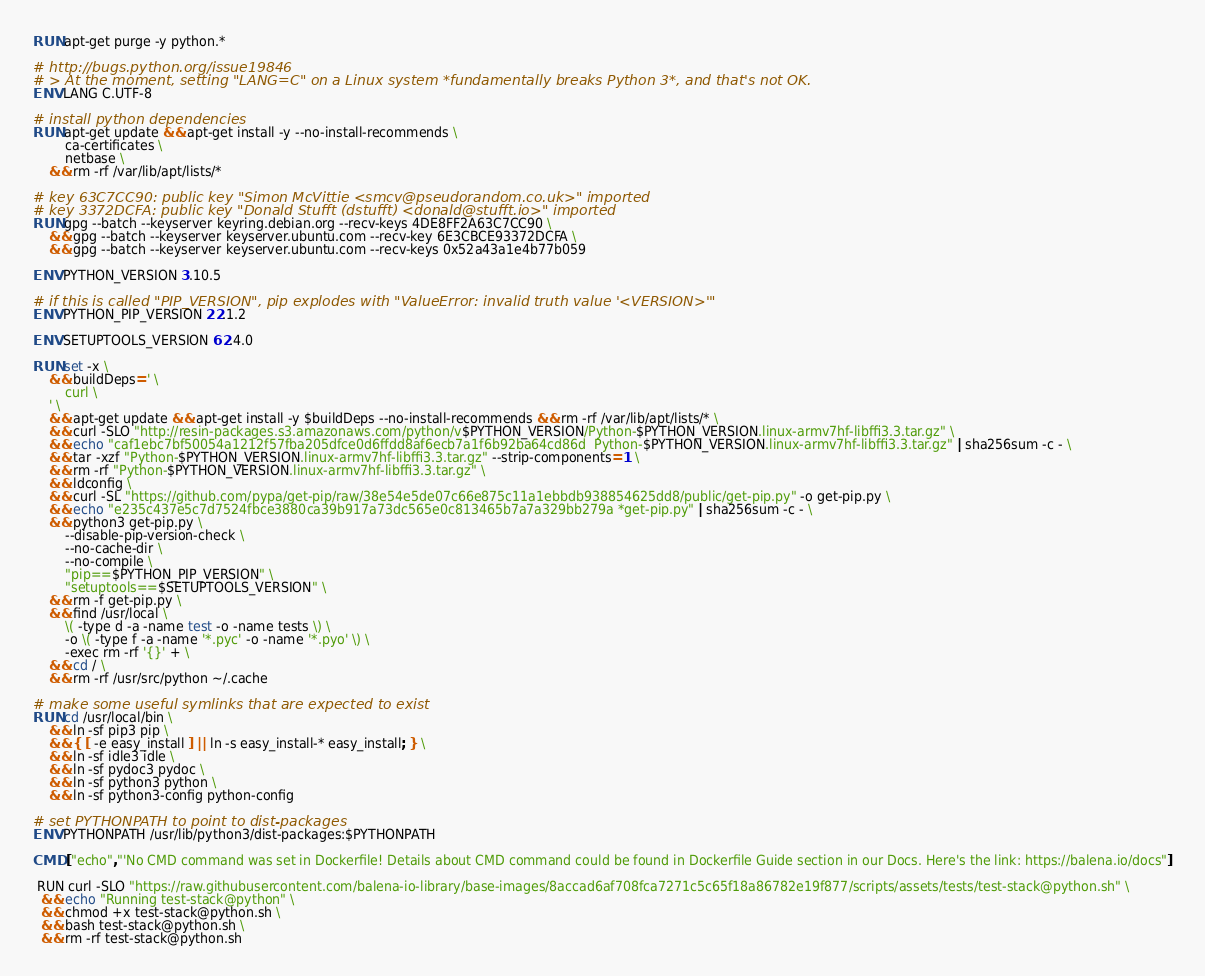<code> <loc_0><loc_0><loc_500><loc_500><_Dockerfile_>RUN apt-get purge -y python.*

# http://bugs.python.org/issue19846
# > At the moment, setting "LANG=C" on a Linux system *fundamentally breaks Python 3*, and that's not OK.
ENV LANG C.UTF-8

# install python dependencies
RUN apt-get update && apt-get install -y --no-install-recommends \
		ca-certificates \
		netbase \
	&& rm -rf /var/lib/apt/lists/*

# key 63C7CC90: public key "Simon McVittie <smcv@pseudorandom.co.uk>" imported
# key 3372DCFA: public key "Donald Stufft (dstufft) <donald@stufft.io>" imported
RUN gpg --batch --keyserver keyring.debian.org --recv-keys 4DE8FF2A63C7CC90 \
	&& gpg --batch --keyserver keyserver.ubuntu.com --recv-key 6E3CBCE93372DCFA \
	&& gpg --batch --keyserver keyserver.ubuntu.com --recv-keys 0x52a43a1e4b77b059

ENV PYTHON_VERSION 3.10.5

# if this is called "PIP_VERSION", pip explodes with "ValueError: invalid truth value '<VERSION>'"
ENV PYTHON_PIP_VERSION 22.1.2

ENV SETUPTOOLS_VERSION 62.4.0

RUN set -x \
	&& buildDeps=' \
		curl \
	' \
	&& apt-get update && apt-get install -y $buildDeps --no-install-recommends && rm -rf /var/lib/apt/lists/* \
	&& curl -SLO "http://resin-packages.s3.amazonaws.com/python/v$PYTHON_VERSION/Python-$PYTHON_VERSION.linux-armv7hf-libffi3.3.tar.gz" \
	&& echo "caf1ebc7bf50054a1212f57fba205dfce0d6ffdd8af6ecb7a1f6b92ba64cd86d  Python-$PYTHON_VERSION.linux-armv7hf-libffi3.3.tar.gz" | sha256sum -c - \
	&& tar -xzf "Python-$PYTHON_VERSION.linux-armv7hf-libffi3.3.tar.gz" --strip-components=1 \
	&& rm -rf "Python-$PYTHON_VERSION.linux-armv7hf-libffi3.3.tar.gz" \
	&& ldconfig \
	&& curl -SL "https://github.com/pypa/get-pip/raw/38e54e5de07c66e875c11a1ebbdb938854625dd8/public/get-pip.py" -o get-pip.py \
    && echo "e235c437e5c7d7524fbce3880ca39b917a73dc565e0c813465b7a7a329bb279a *get-pip.py" | sha256sum -c - \
    && python3 get-pip.py \
        --disable-pip-version-check \
        --no-cache-dir \
        --no-compile \
        "pip==$PYTHON_PIP_VERSION" \
        "setuptools==$SETUPTOOLS_VERSION" \
	&& rm -f get-pip.py \
	&& find /usr/local \
		\( -type d -a -name test -o -name tests \) \
		-o \( -type f -a -name '*.pyc' -o -name '*.pyo' \) \
		-exec rm -rf '{}' + \
	&& cd / \
	&& rm -rf /usr/src/python ~/.cache

# make some useful symlinks that are expected to exist
RUN cd /usr/local/bin \
	&& ln -sf pip3 pip \
	&& { [ -e easy_install ] || ln -s easy_install-* easy_install; } \
	&& ln -sf idle3 idle \
	&& ln -sf pydoc3 pydoc \
	&& ln -sf python3 python \
	&& ln -sf python3-config python-config

# set PYTHONPATH to point to dist-packages
ENV PYTHONPATH /usr/lib/python3/dist-packages:$PYTHONPATH

CMD ["echo","'No CMD command was set in Dockerfile! Details about CMD command could be found in Dockerfile Guide section in our Docs. Here's the link: https://balena.io/docs"]

 RUN curl -SLO "https://raw.githubusercontent.com/balena-io-library/base-images/8accad6af708fca7271c5c65f18a86782e19f877/scripts/assets/tests/test-stack@python.sh" \
  && echo "Running test-stack@python" \
  && chmod +x test-stack@python.sh \
  && bash test-stack@python.sh \
  && rm -rf test-stack@python.sh 
</code> 